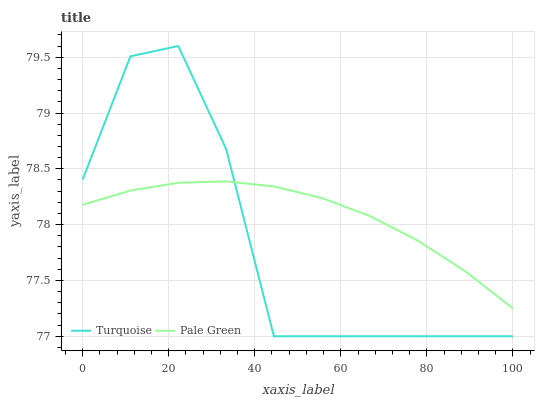Does Pale Green have the minimum area under the curve?
Answer yes or no. No. Is Pale Green the roughest?
Answer yes or no. No. Does Pale Green have the lowest value?
Answer yes or no. No. Does Pale Green have the highest value?
Answer yes or no. No. 